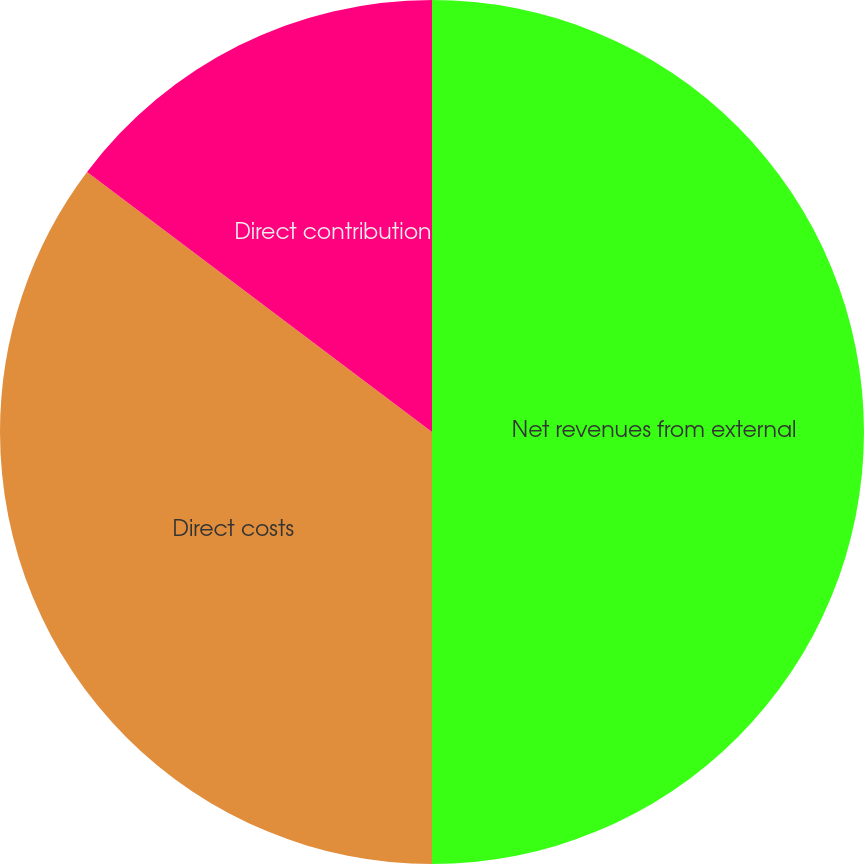Convert chart to OTSL. <chart><loc_0><loc_0><loc_500><loc_500><pie_chart><fcel>Net revenues from external<fcel>Direct costs<fcel>Direct contribution<nl><fcel>50.0%<fcel>35.28%<fcel>14.72%<nl></chart> 